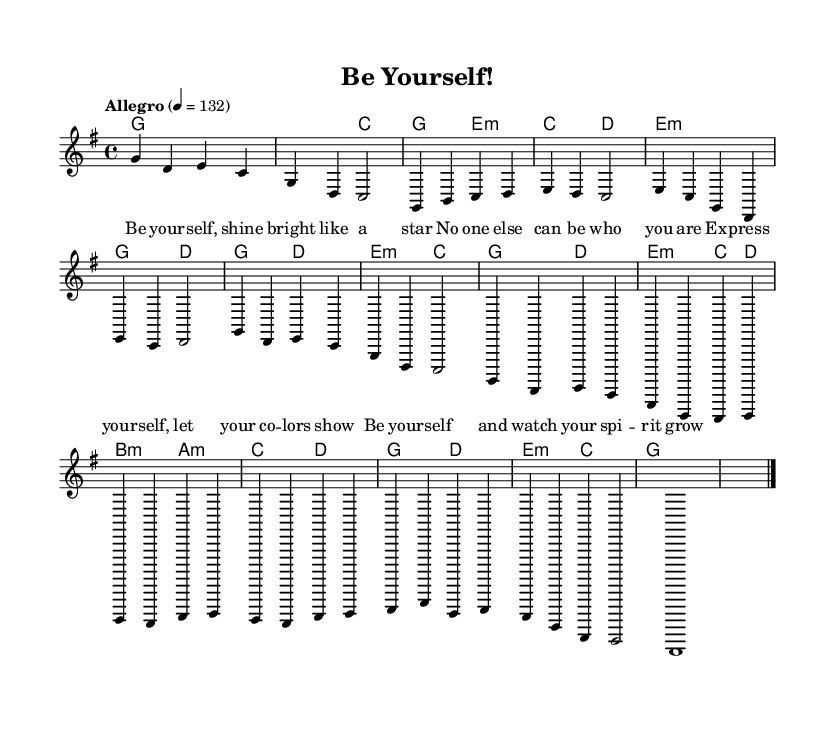What is the key signature of this music? The key signature in the music indicates the presence of one sharp, which corresponds to the G major scale.
Answer: G major What is the time signature of this music? The time signature indicated in the music is 4/4, meaning there are four beats in each measure and the quarter note gets one beat.
Answer: 4/4 What is the tempo marking for this piece? The tempo marking shows that the piece should be played at a speed of 132 beats per minute, marked by the word "Allegro."
Answer: Allegro What notes are played in the Chorus section? In the Chorus section, the notes played are G, D, E, and C, repeated in a specific rhythm pattern.
Answer: G, D, E, C How many measures are in the Bridge section? By counting the measures in the Bridge section, we see there are two measures total before transitioning to the Outro.
Answer: 2 What is the main lyrical theme of the song? The lyrics emphasize themes of self-expression and individuality, encouraging the listener to be themselves and celebrate their uniqueness.
Answer: Self-expression Which section includes the lyrics "Be your -- self, shine bright like a star"? This phrase appears in the first part of the lyrics, specifically during the Intro and leads into the main thematic material of the piece.
Answer: Intro 